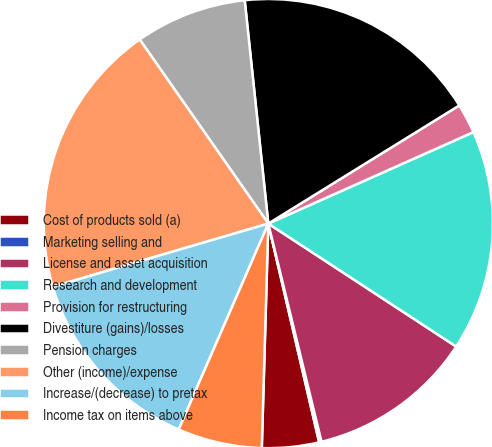Convert chart to OTSL. <chart><loc_0><loc_0><loc_500><loc_500><pie_chart><fcel>Cost of products sold (a)<fcel>Marketing selling and<fcel>License and asset acquisition<fcel>Research and development<fcel>Provision for restructuring<fcel>Divestiture (gains)/losses<fcel>Pension charges<fcel>Other (income)/expense<fcel>Increase/(decrease) to pretax<fcel>Income tax on items above<nl><fcel>4.1%<fcel>0.17%<fcel>11.97%<fcel>15.9%<fcel>2.14%<fcel>17.86%<fcel>8.03%<fcel>19.83%<fcel>13.93%<fcel>6.07%<nl></chart> 